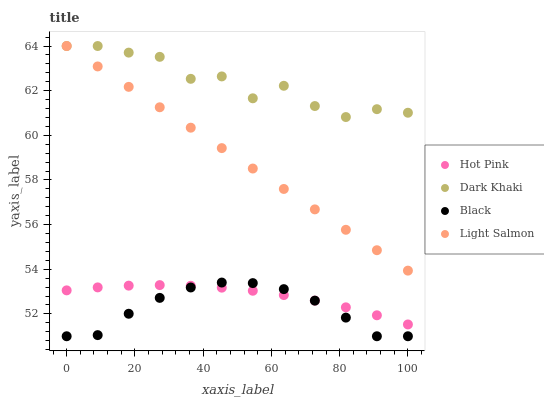Does Black have the minimum area under the curve?
Answer yes or no. Yes. Does Dark Khaki have the maximum area under the curve?
Answer yes or no. Yes. Does Light Salmon have the minimum area under the curve?
Answer yes or no. No. Does Light Salmon have the maximum area under the curve?
Answer yes or no. No. Is Light Salmon the smoothest?
Answer yes or no. Yes. Is Dark Khaki the roughest?
Answer yes or no. Yes. Is Hot Pink the smoothest?
Answer yes or no. No. Is Hot Pink the roughest?
Answer yes or no. No. Does Black have the lowest value?
Answer yes or no. Yes. Does Light Salmon have the lowest value?
Answer yes or no. No. Does Light Salmon have the highest value?
Answer yes or no. Yes. Does Hot Pink have the highest value?
Answer yes or no. No. Is Black less than Dark Khaki?
Answer yes or no. Yes. Is Dark Khaki greater than Hot Pink?
Answer yes or no. Yes. Does Light Salmon intersect Dark Khaki?
Answer yes or no. Yes. Is Light Salmon less than Dark Khaki?
Answer yes or no. No. Is Light Salmon greater than Dark Khaki?
Answer yes or no. No. Does Black intersect Dark Khaki?
Answer yes or no. No. 